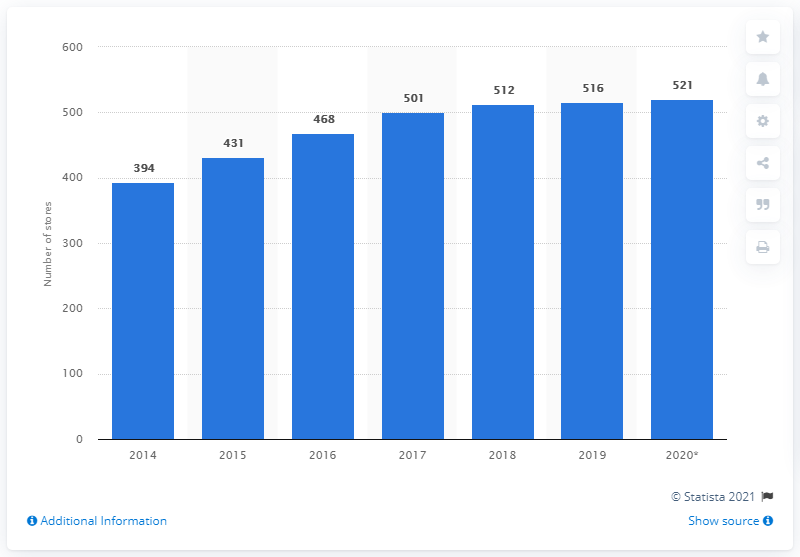Specify some key components in this picture. In 2014, DSW operated 394 stores. As of February 1, 2020, DSW Inc. had a total of 521 stores. 